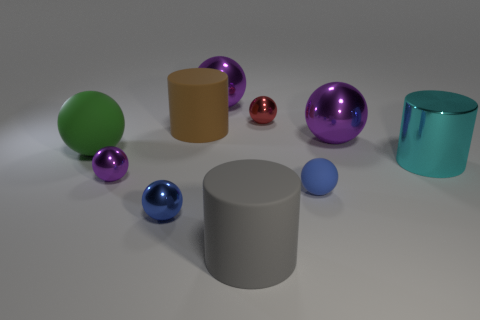There is a gray matte cylinder; what number of tiny purple objects are in front of it?
Your answer should be very brief. 0. What is the color of the large cylinder that is made of the same material as the big gray object?
Offer a very short reply. Brown. What number of matte things are brown things or cyan things?
Your response must be concise. 1. Is the large green object made of the same material as the cyan thing?
Your answer should be compact. No. There is a purple shiny thing that is behind the large brown rubber cylinder; what shape is it?
Offer a terse response. Sphere. Are there any red metal objects behind the big object that is in front of the tiny rubber ball?
Offer a terse response. Yes. Is there a cyan cylinder of the same size as the brown rubber cylinder?
Your answer should be compact. Yes. There is a rubber cylinder in front of the large matte sphere; does it have the same color as the tiny rubber ball?
Your answer should be very brief. No. What is the size of the red object?
Give a very brief answer. Small. What is the size of the purple thing in front of the large metallic sphere that is on the right side of the small matte object?
Keep it short and to the point. Small. 